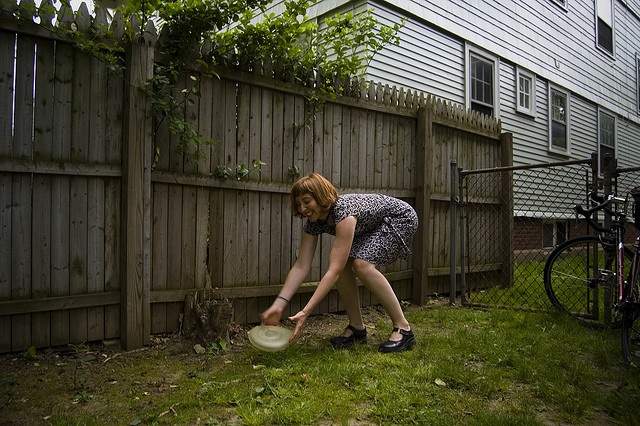Describe the objects in this image and their specific colors. I can see people in black, gray, and maroon tones, bicycle in black, darkgreen, and gray tones, and frisbee in black, gray, olive, and darkgray tones in this image. 